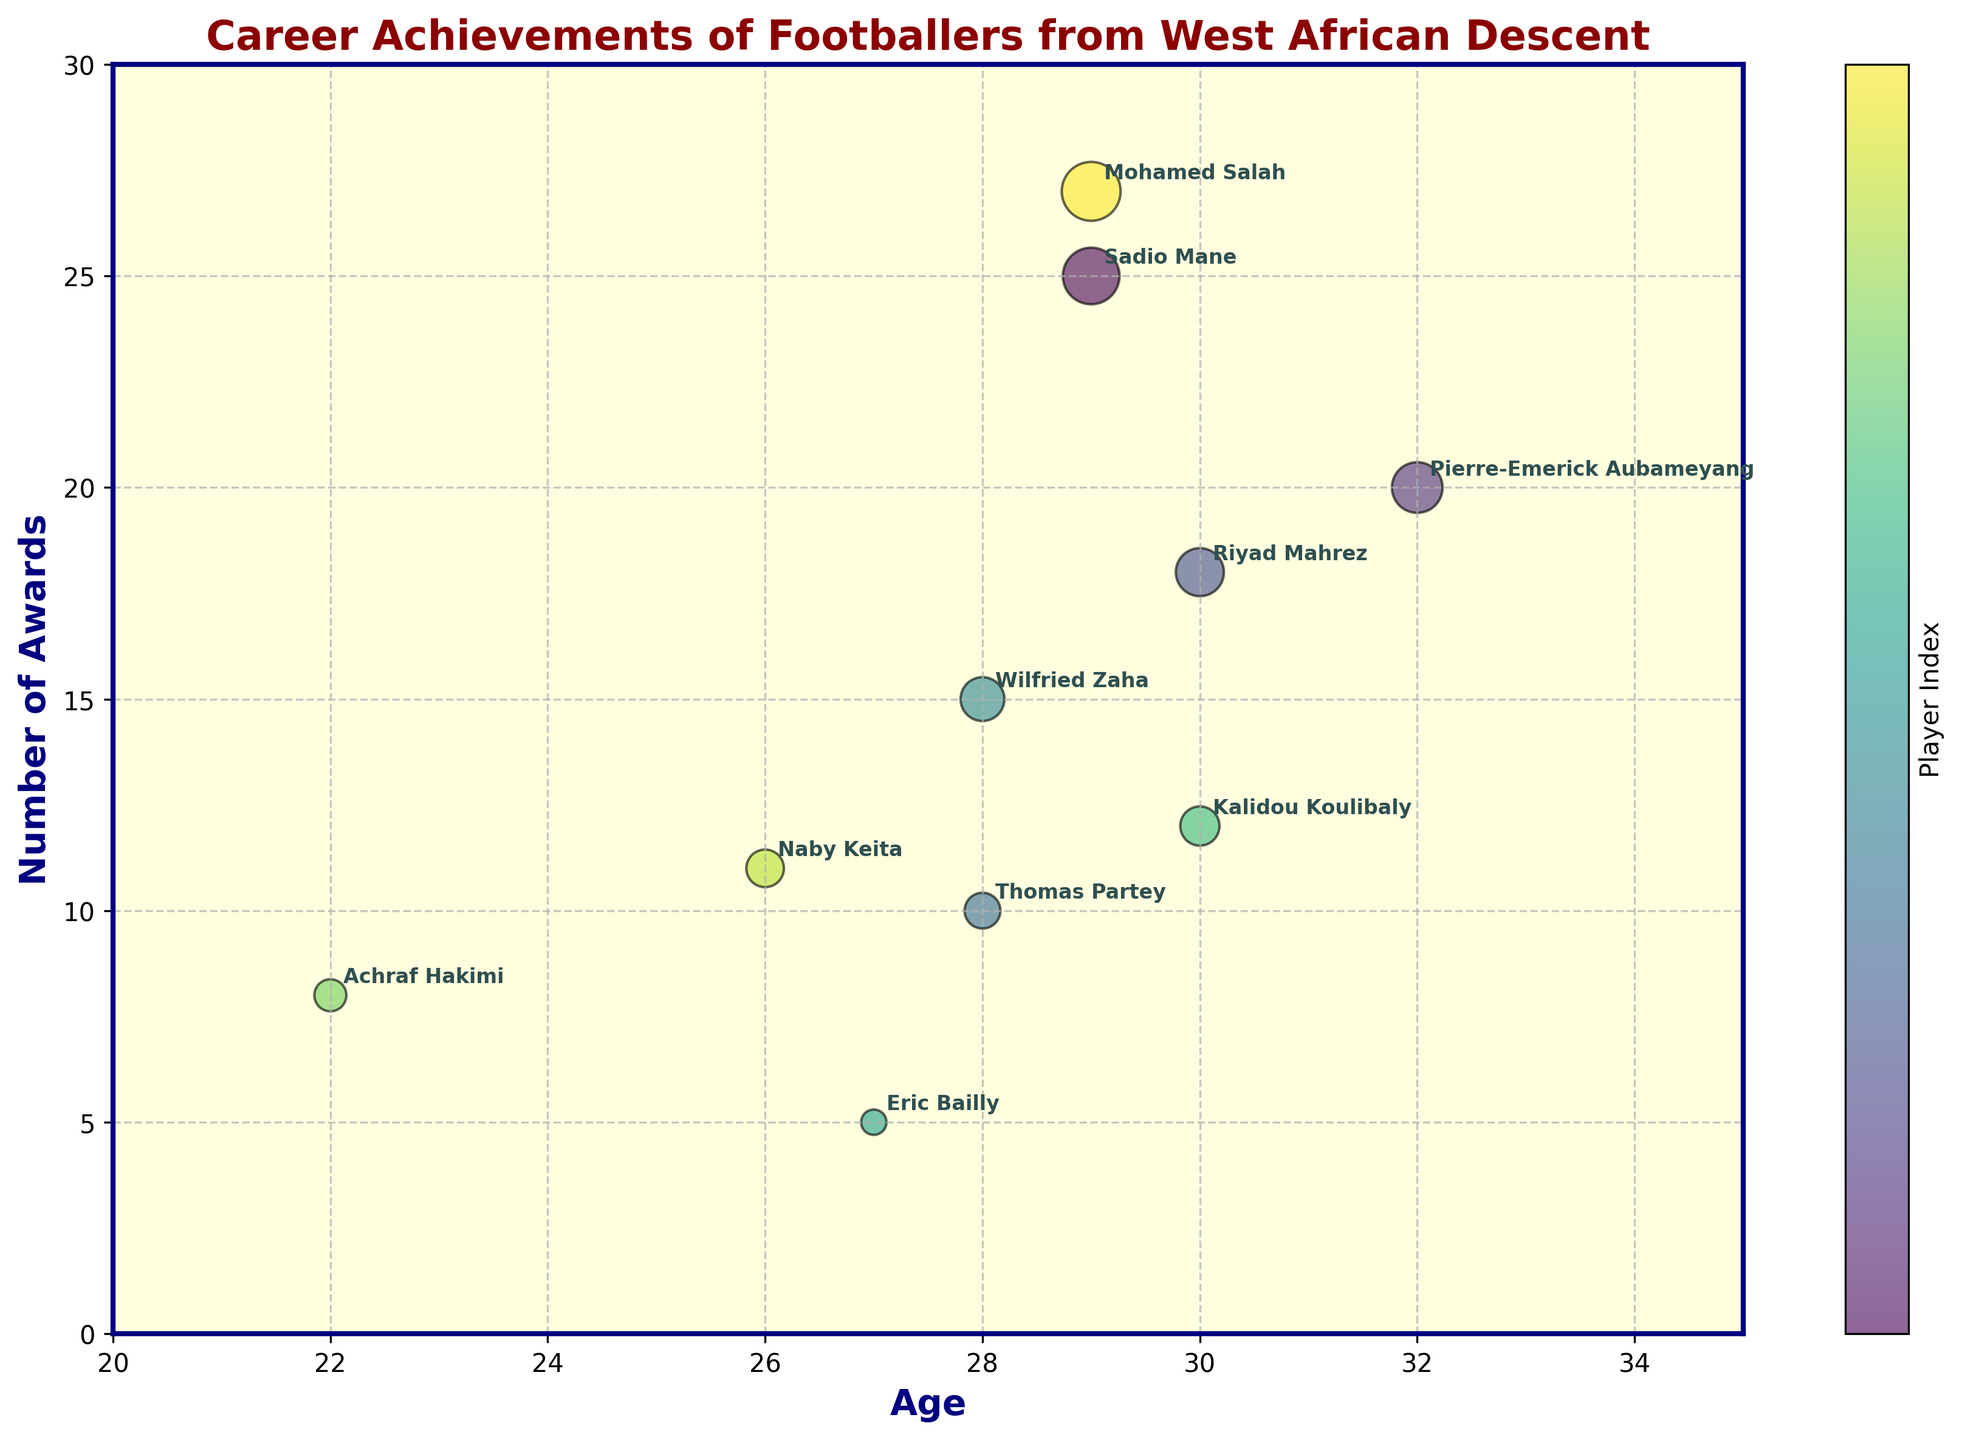What is the title of the chart? The title is usually located at the top of the chart. By reading it, you can identify that it provides an overview of the chart content.
Answer: Career Achievements of Footballers from West African Descent How many footballers in the chart are identified as forwards? To answer this, look for the players' names whose playing positions are indicated as forward in the data annotations.
Answer: 4 Who is the footballer with the highest number of awards? Identify the highest point on the Number of Awards axis and find the corresponding player annotated by name.
Answer: Mohamed Salah Who is the youngest player in the chart and how many awards do they have? Find the lowest point on the Age axis and identify the player's name and the corresponding Number of Awards.
Answer: Achraf Hakimi, 8 awards What is the difference in the number of awards between Sadio Mane and Pierre-Emerick Aubameyang? Subtract the number of awards of Pierre-Emerick Aubameyang from that of Sadio Mane by finding their positions on the chart and reading the Number of Awards values.
Answer: 5 awards Which player represents the largest bubble and what does the size of the bubble indicate? The largest bubble corresponds to the player with the most awards. Identify the player by looking at the chart's annotations and bubble sizes. The size represents the number of awards.
Answer: Mohamed Salah, Number of Awards Which two players have earned a similar number of awards? Look for bubbles that are of similar size and located at close positions along the Number of Awards axis, then identify the players from the names annotated.
Answer: Wilfried Zaha and Naby Keita How many midfielders are there, and what is the average number of awards among them? Identify the midfielders from the chart based on their playing positions, then calculate the average number of awards by summing their awards and dividing by the number of midfielders.
Answer: 3 midfielders, 13 awards Of the players aged 28, who has the greatest number of awards? Look at the points on the chart where the Age is marked as 28 and compare the Number of Awards. Identify the corresponding player from annotations.
Answer: Wilfried Zaha 